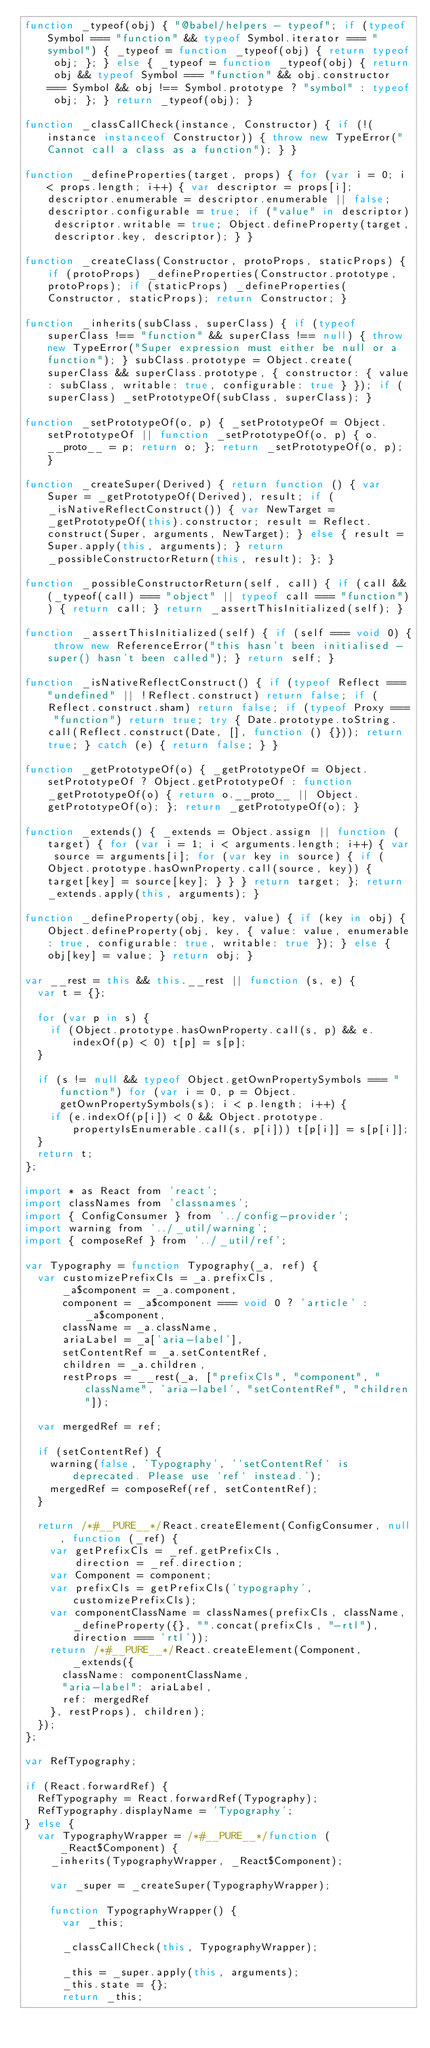Convert code to text. <code><loc_0><loc_0><loc_500><loc_500><_JavaScript_>function _typeof(obj) { "@babel/helpers - typeof"; if (typeof Symbol === "function" && typeof Symbol.iterator === "symbol") { _typeof = function _typeof(obj) { return typeof obj; }; } else { _typeof = function _typeof(obj) { return obj && typeof Symbol === "function" && obj.constructor === Symbol && obj !== Symbol.prototype ? "symbol" : typeof obj; }; } return _typeof(obj); }

function _classCallCheck(instance, Constructor) { if (!(instance instanceof Constructor)) { throw new TypeError("Cannot call a class as a function"); } }

function _defineProperties(target, props) { for (var i = 0; i < props.length; i++) { var descriptor = props[i]; descriptor.enumerable = descriptor.enumerable || false; descriptor.configurable = true; if ("value" in descriptor) descriptor.writable = true; Object.defineProperty(target, descriptor.key, descriptor); } }

function _createClass(Constructor, protoProps, staticProps) { if (protoProps) _defineProperties(Constructor.prototype, protoProps); if (staticProps) _defineProperties(Constructor, staticProps); return Constructor; }

function _inherits(subClass, superClass) { if (typeof superClass !== "function" && superClass !== null) { throw new TypeError("Super expression must either be null or a function"); } subClass.prototype = Object.create(superClass && superClass.prototype, { constructor: { value: subClass, writable: true, configurable: true } }); if (superClass) _setPrototypeOf(subClass, superClass); }

function _setPrototypeOf(o, p) { _setPrototypeOf = Object.setPrototypeOf || function _setPrototypeOf(o, p) { o.__proto__ = p; return o; }; return _setPrototypeOf(o, p); }

function _createSuper(Derived) { return function () { var Super = _getPrototypeOf(Derived), result; if (_isNativeReflectConstruct()) { var NewTarget = _getPrototypeOf(this).constructor; result = Reflect.construct(Super, arguments, NewTarget); } else { result = Super.apply(this, arguments); } return _possibleConstructorReturn(this, result); }; }

function _possibleConstructorReturn(self, call) { if (call && (_typeof(call) === "object" || typeof call === "function")) { return call; } return _assertThisInitialized(self); }

function _assertThisInitialized(self) { if (self === void 0) { throw new ReferenceError("this hasn't been initialised - super() hasn't been called"); } return self; }

function _isNativeReflectConstruct() { if (typeof Reflect === "undefined" || !Reflect.construct) return false; if (Reflect.construct.sham) return false; if (typeof Proxy === "function") return true; try { Date.prototype.toString.call(Reflect.construct(Date, [], function () {})); return true; } catch (e) { return false; } }

function _getPrototypeOf(o) { _getPrototypeOf = Object.setPrototypeOf ? Object.getPrototypeOf : function _getPrototypeOf(o) { return o.__proto__ || Object.getPrototypeOf(o); }; return _getPrototypeOf(o); }

function _extends() { _extends = Object.assign || function (target) { for (var i = 1; i < arguments.length; i++) { var source = arguments[i]; for (var key in source) { if (Object.prototype.hasOwnProperty.call(source, key)) { target[key] = source[key]; } } } return target; }; return _extends.apply(this, arguments); }

function _defineProperty(obj, key, value) { if (key in obj) { Object.defineProperty(obj, key, { value: value, enumerable: true, configurable: true, writable: true }); } else { obj[key] = value; } return obj; }

var __rest = this && this.__rest || function (s, e) {
  var t = {};

  for (var p in s) {
    if (Object.prototype.hasOwnProperty.call(s, p) && e.indexOf(p) < 0) t[p] = s[p];
  }

  if (s != null && typeof Object.getOwnPropertySymbols === "function") for (var i = 0, p = Object.getOwnPropertySymbols(s); i < p.length; i++) {
    if (e.indexOf(p[i]) < 0 && Object.prototype.propertyIsEnumerable.call(s, p[i])) t[p[i]] = s[p[i]];
  }
  return t;
};

import * as React from 'react';
import classNames from 'classnames';
import { ConfigConsumer } from '../config-provider';
import warning from '../_util/warning';
import { composeRef } from '../_util/ref';

var Typography = function Typography(_a, ref) {
  var customizePrefixCls = _a.prefixCls,
      _a$component = _a.component,
      component = _a$component === void 0 ? 'article' : _a$component,
      className = _a.className,
      ariaLabel = _a['aria-label'],
      setContentRef = _a.setContentRef,
      children = _a.children,
      restProps = __rest(_a, ["prefixCls", "component", "className", 'aria-label', "setContentRef", "children"]);

  var mergedRef = ref;

  if (setContentRef) {
    warning(false, 'Typography', '`setContentRef` is deprecated. Please use `ref` instead.');
    mergedRef = composeRef(ref, setContentRef);
  }

  return /*#__PURE__*/React.createElement(ConfigConsumer, null, function (_ref) {
    var getPrefixCls = _ref.getPrefixCls,
        direction = _ref.direction;
    var Component = component;
    var prefixCls = getPrefixCls('typography', customizePrefixCls);
    var componentClassName = classNames(prefixCls, className, _defineProperty({}, "".concat(prefixCls, "-rtl"), direction === 'rtl'));
    return /*#__PURE__*/React.createElement(Component, _extends({
      className: componentClassName,
      "aria-label": ariaLabel,
      ref: mergedRef
    }, restProps), children);
  });
};

var RefTypography;

if (React.forwardRef) {
  RefTypography = React.forwardRef(Typography);
  RefTypography.displayName = 'Typography';
} else {
  var TypographyWrapper = /*#__PURE__*/function (_React$Component) {
    _inherits(TypographyWrapper, _React$Component);

    var _super = _createSuper(TypographyWrapper);

    function TypographyWrapper() {
      var _this;

      _classCallCheck(this, TypographyWrapper);

      _this = _super.apply(this, arguments);
      _this.state = {};
      return _this;</code> 